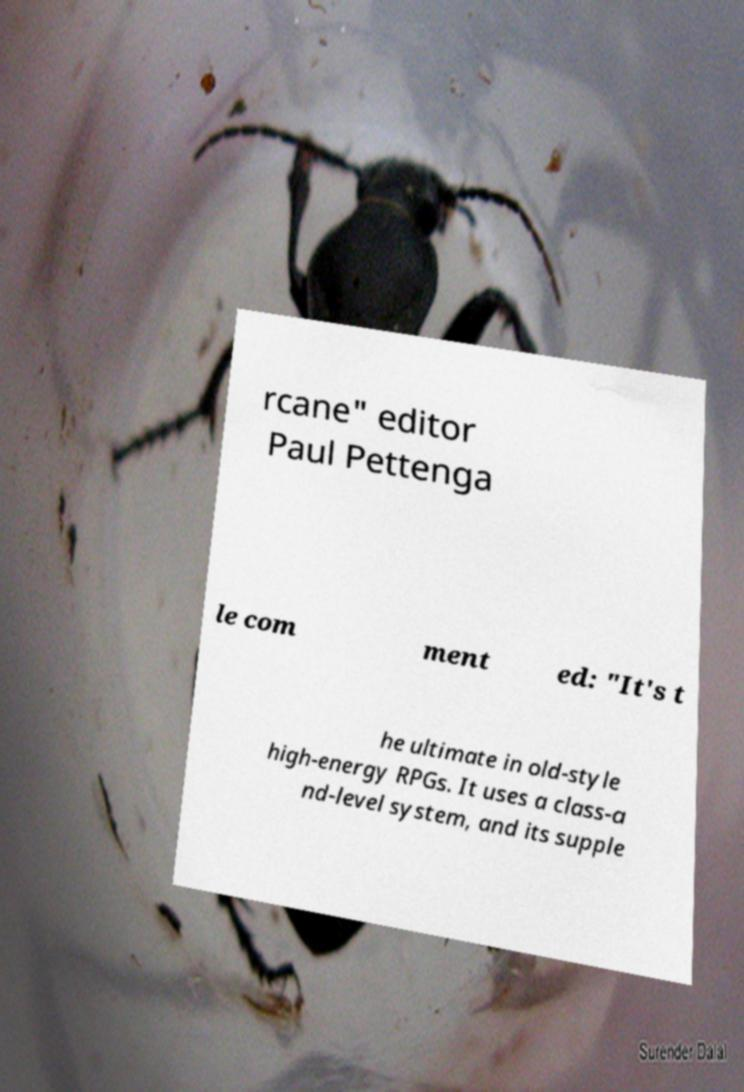Could you extract and type out the text from this image? rcane" editor Paul Pettenga le com ment ed: "It's t he ultimate in old-style high-energy RPGs. It uses a class-a nd-level system, and its supple 